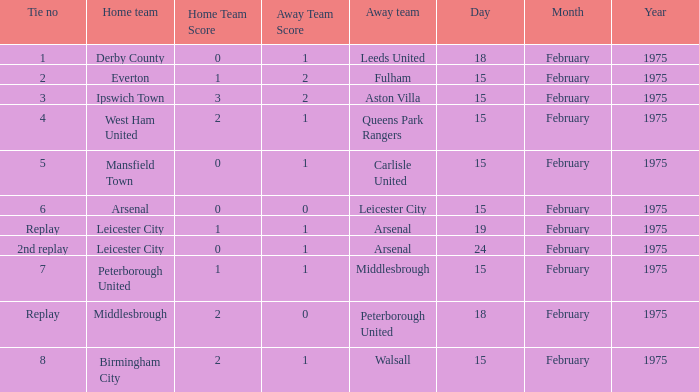What was the date when the away team was the leeds united? 18 February 1975. Parse the full table. {'header': ['Tie no', 'Home team', 'Home Team Score', 'Away Team Score', 'Away team', 'Day', 'Month', 'Year'], 'rows': [['1', 'Derby County', '0', '1', 'Leeds United', '18', 'February', '1975'], ['2', 'Everton', '1', '2', 'Fulham', '15', 'February', '1975'], ['3', 'Ipswich Town', '3', '2', 'Aston Villa', '15', 'February', '1975'], ['4', 'West Ham United', '2', '1', 'Queens Park Rangers', '15', 'February', '1975'], ['5', 'Mansfield Town', '0', '1', 'Carlisle United', '15', 'February', '1975'], ['6', 'Arsenal', '0', '0', 'Leicester City', '15', 'February', '1975'], ['Replay', 'Leicester City', '1', '1', 'Arsenal', '19', 'February', '1975'], ['2nd replay', 'Leicester City', '0', '1', 'Arsenal', '24', 'February', '1975'], ['7', 'Peterborough United', '1', '1', 'Middlesbrough', '15', 'February', '1975'], ['Replay', 'Middlesbrough', '2', '0', 'Peterborough United', '18', 'February', '1975'], ['8', 'Birmingham City', '2', '1', 'Walsall', '15', 'February', '1975']]} 